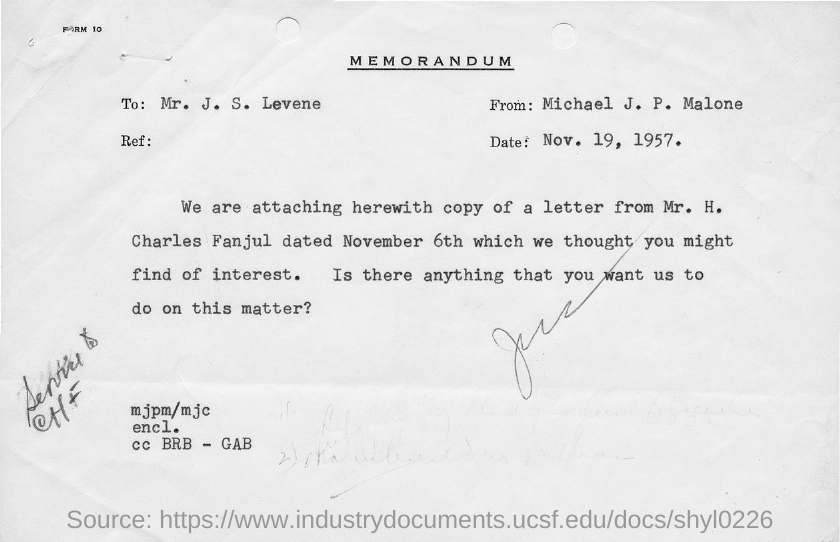Identify some key points in this picture. The title of the document is 'Memorandum.' 